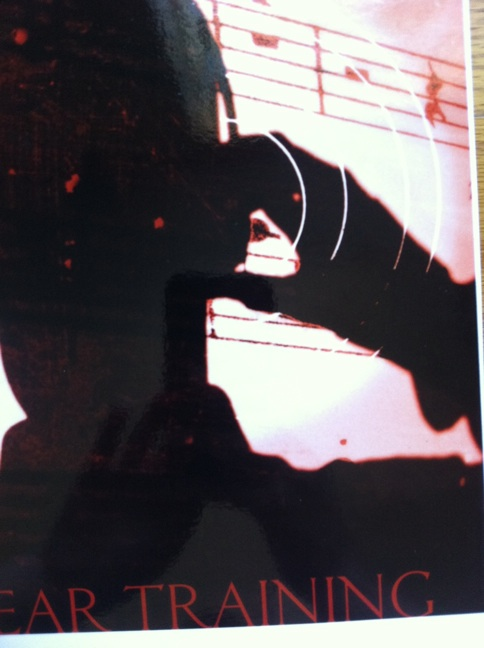Using your wildest imagination, turn this image into a science fiction story premise. In the distant future, Earth has discovered that sound waves can be harnessed to manipulate time. The image depicts Dr. Lyra, a sound engineer, strumming a temporal-shift guitar. This instrument, when played with precise ear training, can open wormholes to different eras. As Lyra practices, dark figures from various timelines merge, creating a nexus of history and future. The sheet music in the background is a complex temporal map, and Lyra must decipher it to prevent a catastrophic time collision that could rewrite human history. 